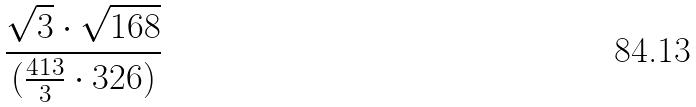<formula> <loc_0><loc_0><loc_500><loc_500>\frac { \sqrt { 3 } \cdot \sqrt { 1 6 8 } } { ( \frac { 4 1 3 } { 3 } \cdot 3 2 6 ) }</formula> 